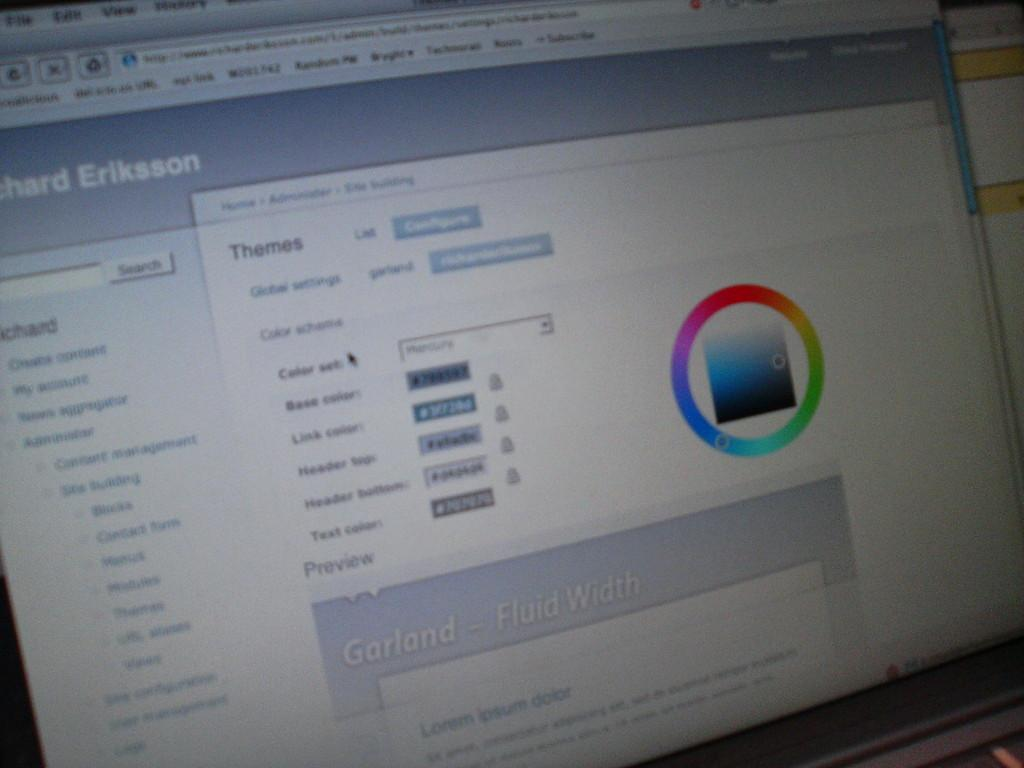Provide a one-sentence caption for the provided image. A monitor shows a window with various themes displayed. 